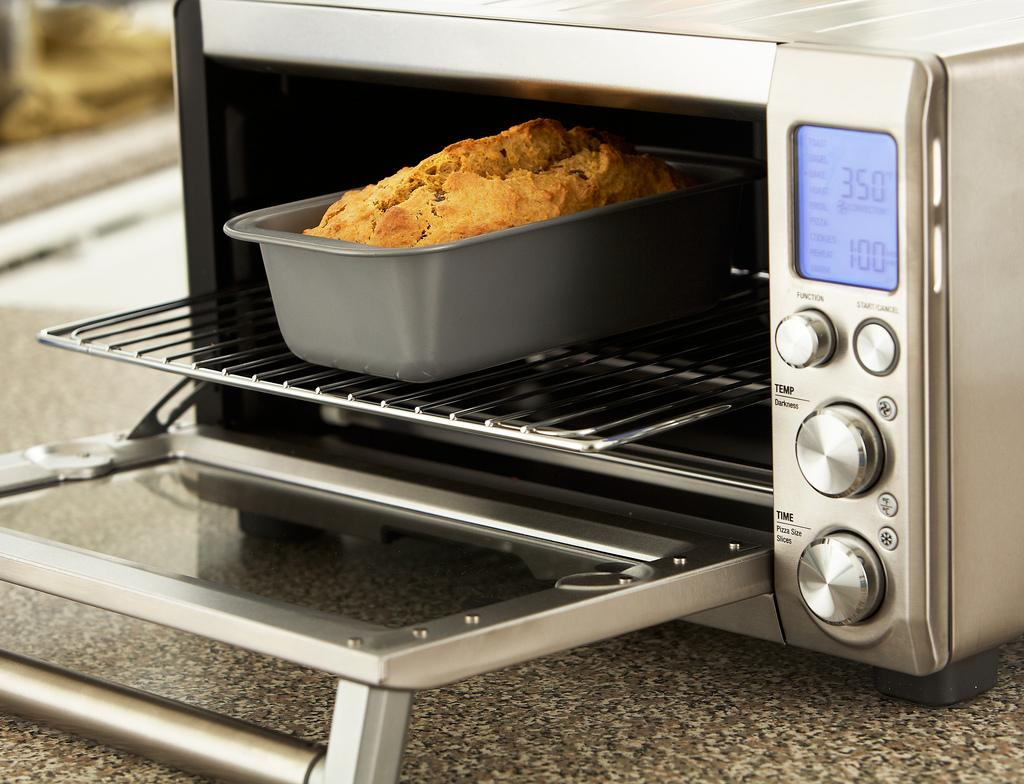<image>
Share a concise interpretation of the image provided. A toaster oven has settings for TEMP and TIME on the front. 